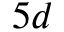<formula> <loc_0><loc_0><loc_500><loc_500>5 d</formula> 